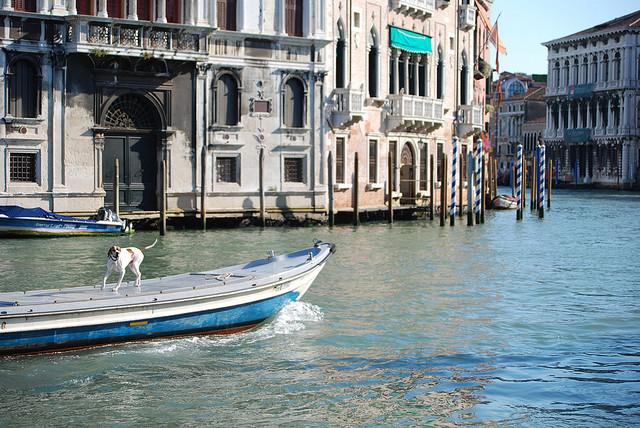Where are the blue and white striped poles?
Be succinct. In water. Is the dog on a boat?
Write a very short answer. Yes. What living creature is shown?
Concise answer only. Dog. 